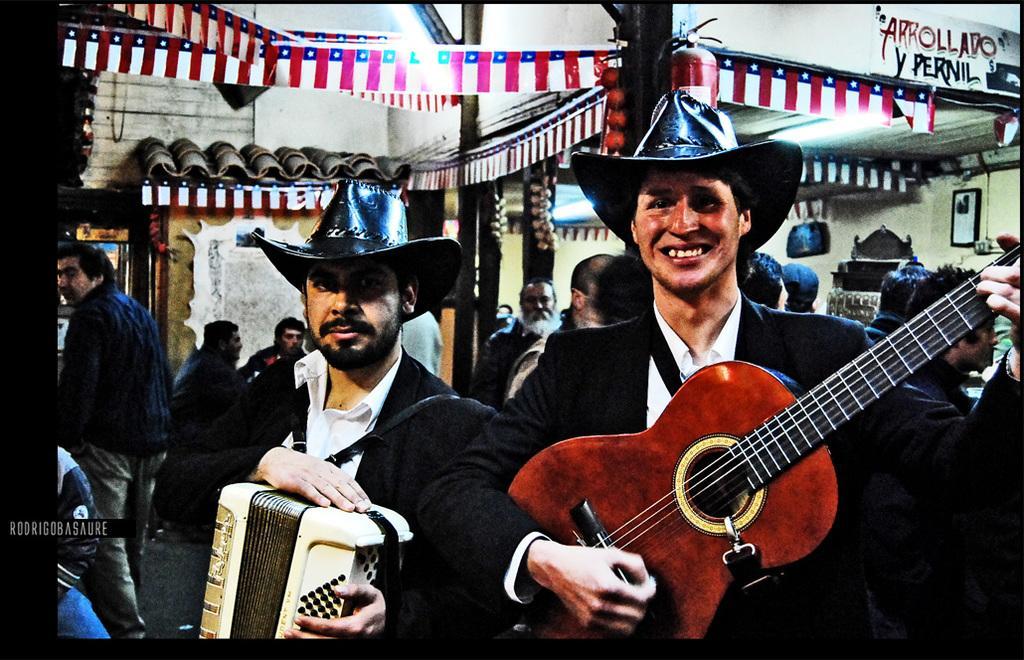Can you describe this image briefly? This is the picture of two people holding a guitar and a drum in black suits and hats. 